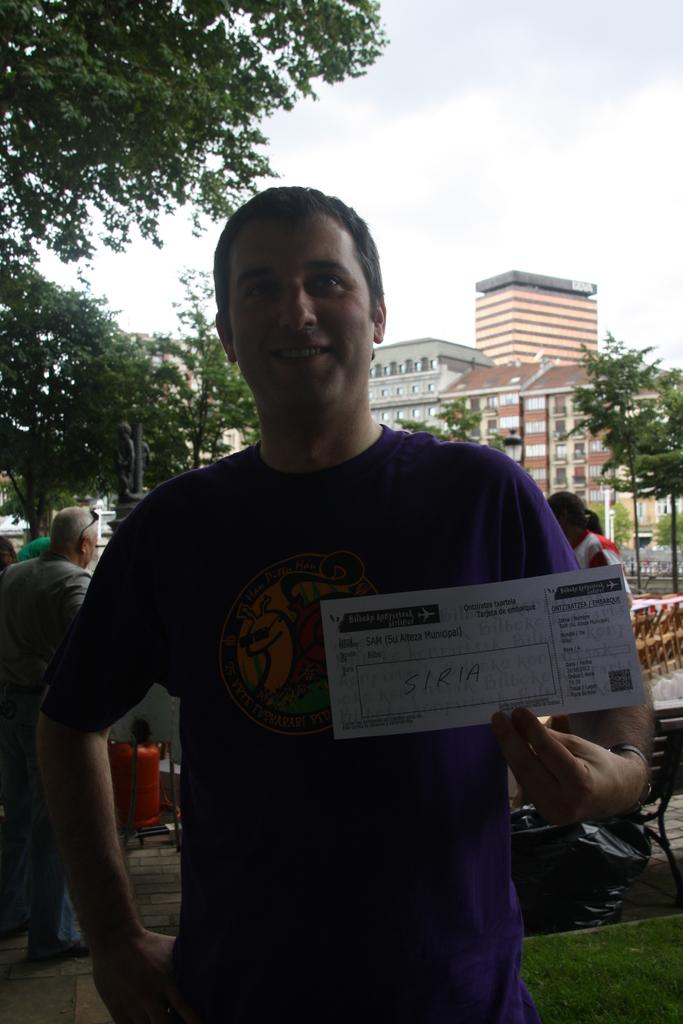What is the man holding in the image? The man is holding a paper in the image. What type of structures can be seen in the image? There are buildings in the image. What other natural elements are present in the image? There are trees in the image. What part of the natural environment is visible in the image? The sky is visible in the image. What type of joke can be seen written on the paper the man is holding? There is no joke visible on the paper the man is holding; it is a paper, and the content is not specified in the image. 